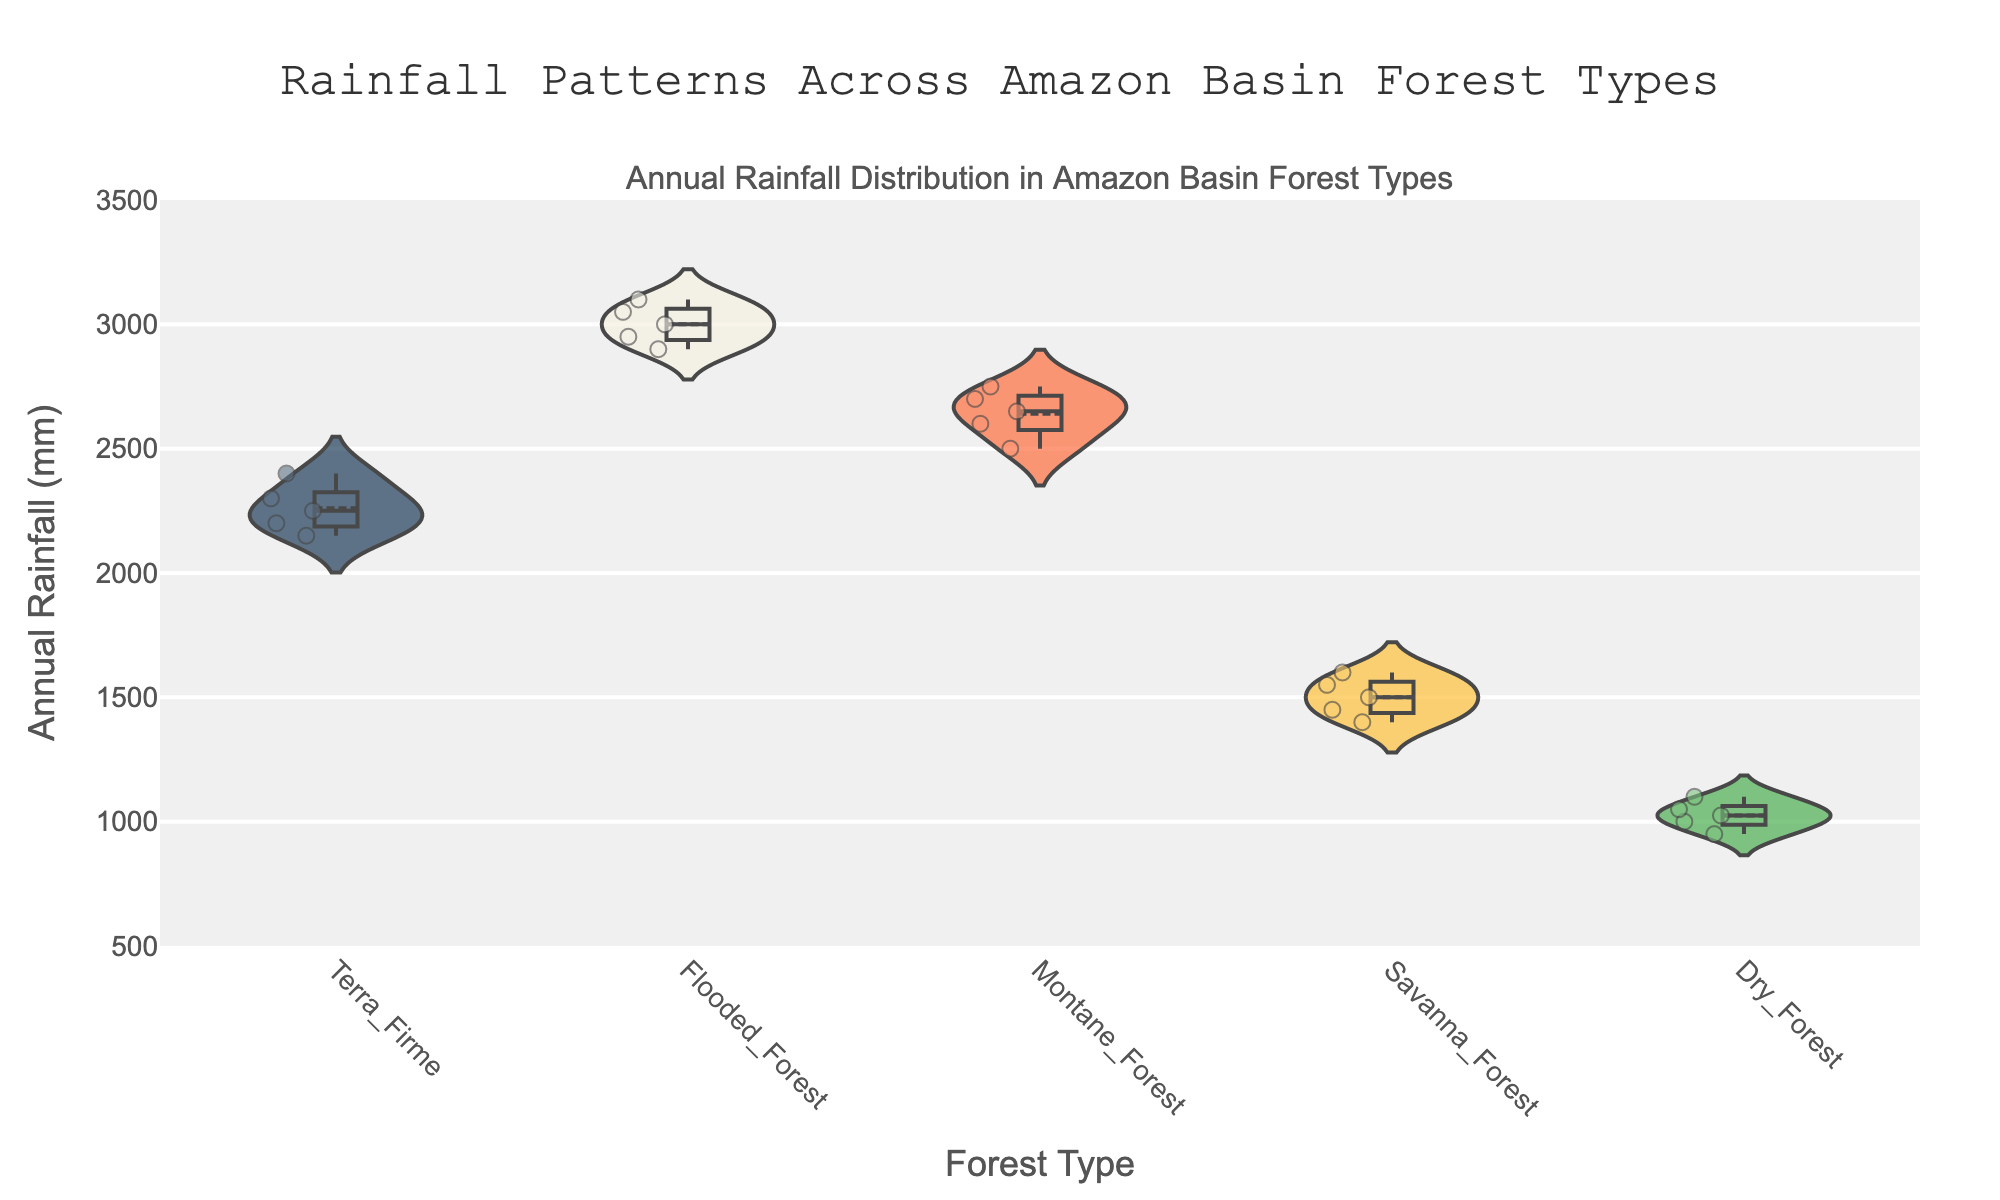What is the title of the figure? The title is usually clearly stated at the top of the figure.
Answer: Rainfall Patterns Across Amazon Basin Forest Types Which forest type has the highest median annual rainfall? In violin plots, the median is typically shown as a line within the box plot embedded in the violin. The tallest median line will indicate the highest median annual rainfall.
Answer: Flooded_Forest How many forest types are compared in the figure? The number of distinct forest types can be counted from the x-axis labels or from the number of separate violins.
Answer: 5 What range of annual rainfall can be observed in Terra Firme forests? The range in a violin plot can be identified by looking at the spread of the data points, usually extending from the minimum to the maximum values.
Answer: 2150 to 2400 mm Compare the annual rainfall between Savanna Forest and Montane Forest. Look at the height and distribution of the data points in both violins to compare. Savanna has lower rainfall values while Montane has higher and more consistent values.
Answer: Savanna Forest has lower annual rainfall compared to Montane Forest Which forest type shows the greatest variability in annual rainfall? Variability is indicated by the width and spread of the violin plot. The wider and more spread out the plot, the greater the variability.
Answer: Flooded_Forest What is the approximate median annual rainfall for Dry Forest? Within the violin plot, find the center line in the embedded box plot which represents the median.
Answer: Approximately 1000 mm How does the mean annual rainfall of Terra Firme compare to that of Dry Forest? Mean values are typically shown by a line within a violin plot. Compare the vertical positions of these lines in the violins for Terra Firme and Dry Forest.
Answer: Terra Firme has a higher mean annual rainfall compared to Dry Forest What is the median value of annual rainfall in the Montane Forests? The violin plot shows the median value as a line within the embedded box plot. Look for this line in the Montane Forest violin.
Answer: 2650 mm Which forest type has the smallest spread in annual rainfall? The smallest spread can be identified by the narrowest and least extended violin plot, indicating less variability.
Answer: Dry_Forest 